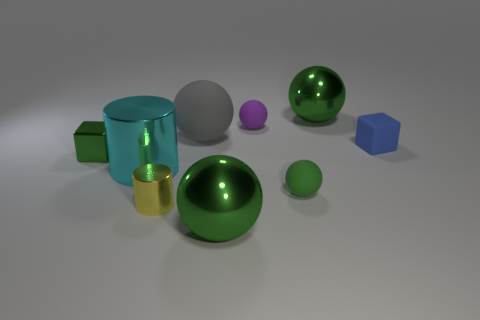Subtract all brown cylinders. How many green balls are left? 3 Subtract all small rubber balls. How many balls are left? 3 Subtract all purple spheres. How many spheres are left? 4 Subtract all cylinders. How many objects are left? 7 Subtract 0 brown blocks. How many objects are left? 9 Subtract all purple spheres. Subtract all blue blocks. How many spheres are left? 4 Subtract all gray rubber spheres. Subtract all gray rubber objects. How many objects are left? 7 Add 8 big gray balls. How many big gray balls are left? 9 Add 4 gray cubes. How many gray cubes exist? 4 